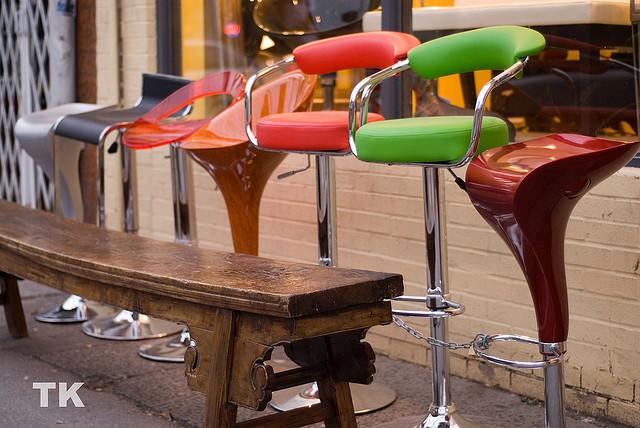What is the brown structure likely made of? Please explain your reasoning. wood. It is carved and you can see the grain in it 